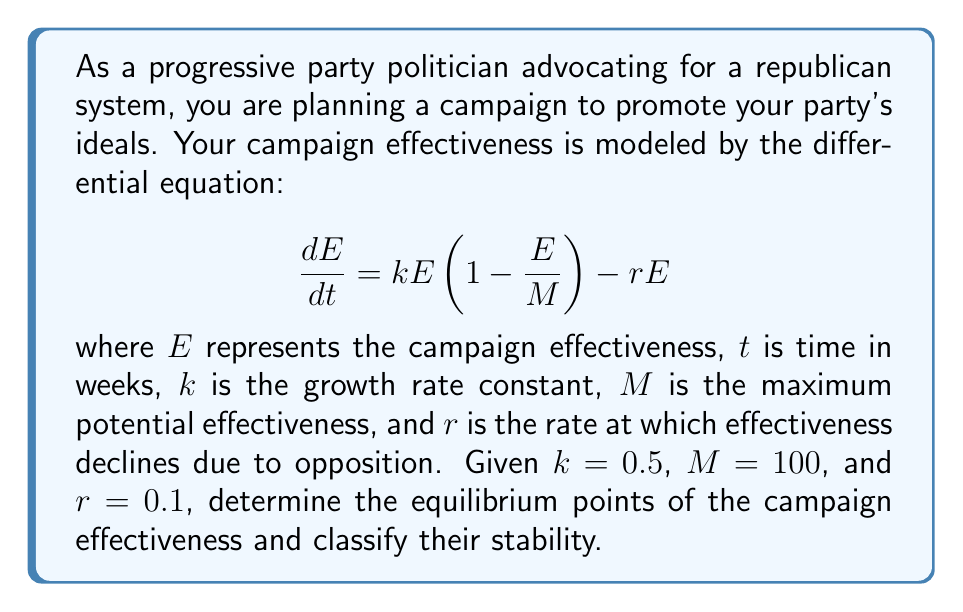What is the answer to this math problem? To solve this problem, we need to follow these steps:

1) First, we need to find the equilibrium points. These occur when $\frac{dE}{dt} = 0$.

2) Set up the equation:
   $$0 = kE(1 - \frac{E}{M}) - rE$$

3) Substitute the given values:
   $$0 = 0.5E(1 - \frac{E}{100}) - 0.1E$$

4) Simplify:
   $$0 = 0.5E - 0.005E^2 - 0.1E = 0.4E - 0.005E^2$$

5) Factor out E:
   $$E(0.4 - 0.005E) = 0$$

6) Solve for E:
   $E = 0$ or $0.4 - 0.005E = 0$
   $E = 0$ or $E = 80$

7) To classify the stability, we need to evaluate $\frac{d}{dE}(\frac{dE}{dt})$ at each equilibrium point:

   $$\frac{d}{dE}(\frac{dE}{dt}) = k - \frac{2kE}{M} - r = 0.5 - \frac{E}{50} - 0.1$$

8) At $E = 0$:
   $0.5 - 0 - 0.1 = 0.4 > 0$, so this is an unstable equilibrium.

9) At $E = 80$:
   $0.5 - \frac{80}{50} - 0.1 = -1.2 < 0$, so this is a stable equilibrium.
Answer: The equilibrium points are $E = 0$ (unstable) and $E = 80$ (stable). 